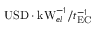Convert formula to latex. <formula><loc_0><loc_0><loc_500><loc_500>U S D \cdot k W _ { e l } ^ { - 1 } / t _ { E C } ^ { - 1 }</formula> 